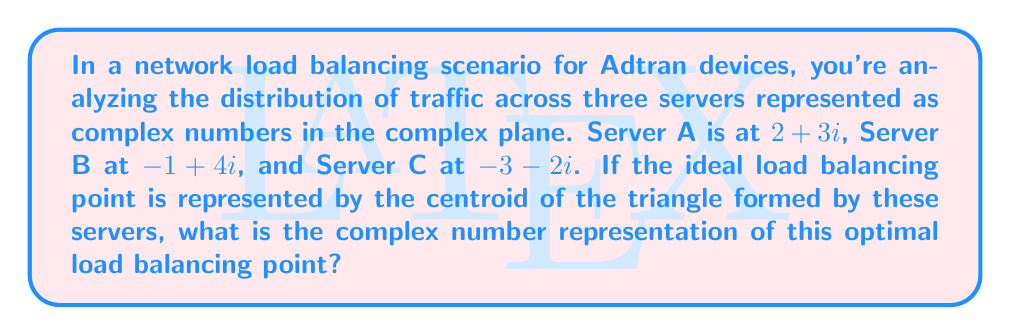Help me with this question. To find the centroid of the triangle formed by the three servers, we need to follow these steps:

1. Identify the complex numbers representing each server:
   Server A: $z_1 = 2+3i$
   Server B: $z_2 = -1+4i$
   Server C: $z_3 = -3-2i$

2. Calculate the centroid using the formula:
   $$ z_{centroid} = \frac{z_1 + z_2 + z_3}{3} $$

3. Substitute the values:
   $$ z_{centroid} = \frac{(2+3i) + (-1+4i) + (-3-2i)}{3} $$

4. Simplify the numerator:
   $$ z_{centroid} = \frac{-2+5i}{3} $$

5. Separate the real and imaginary parts:
   $$ z_{centroid} = \frac{-2}{3} + \frac{5}{3}i $$

This complex number represents the optimal load balancing point in the complex plane, where the real part indicates the position along the x-axis and the imaginary part indicates the position along the y-axis.
Answer: $-\frac{2}{3} + \frac{5}{3}i$ 